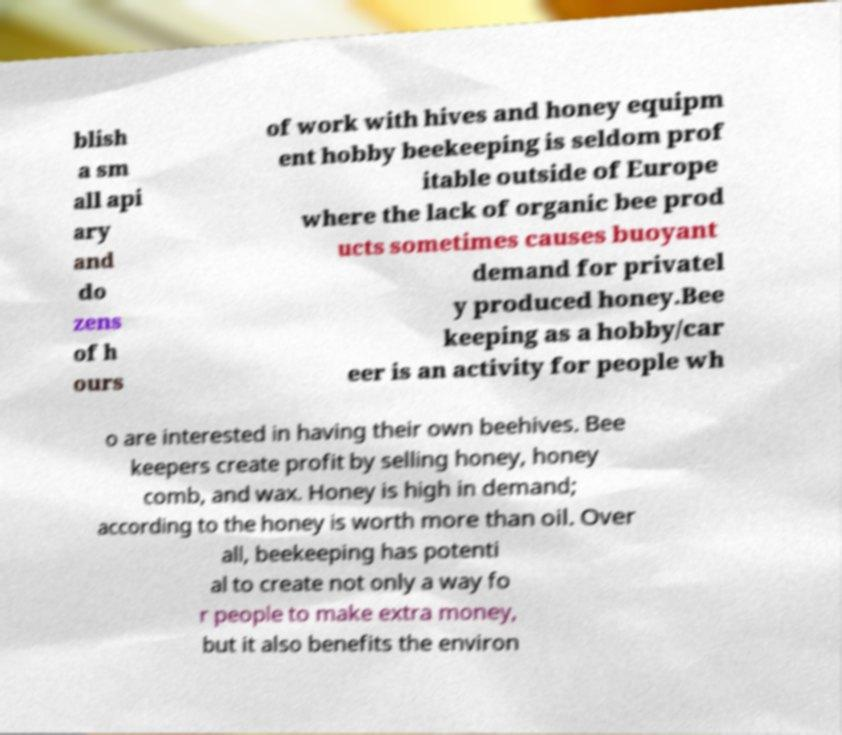Please read and relay the text visible in this image. What does it say? blish a sm all api ary and do zens of h ours of work with hives and honey equipm ent hobby beekeeping is seldom prof itable outside of Europe where the lack of organic bee prod ucts sometimes causes buoyant demand for privatel y produced honey.Bee keeping as a hobby/car eer is an activity for people wh o are interested in having their own beehives. Bee keepers create profit by selling honey, honey comb, and wax. Honey is high in demand; according to the honey is worth more than oil. Over all, beekeeping has potenti al to create not only a way fo r people to make extra money, but it also benefits the environ 